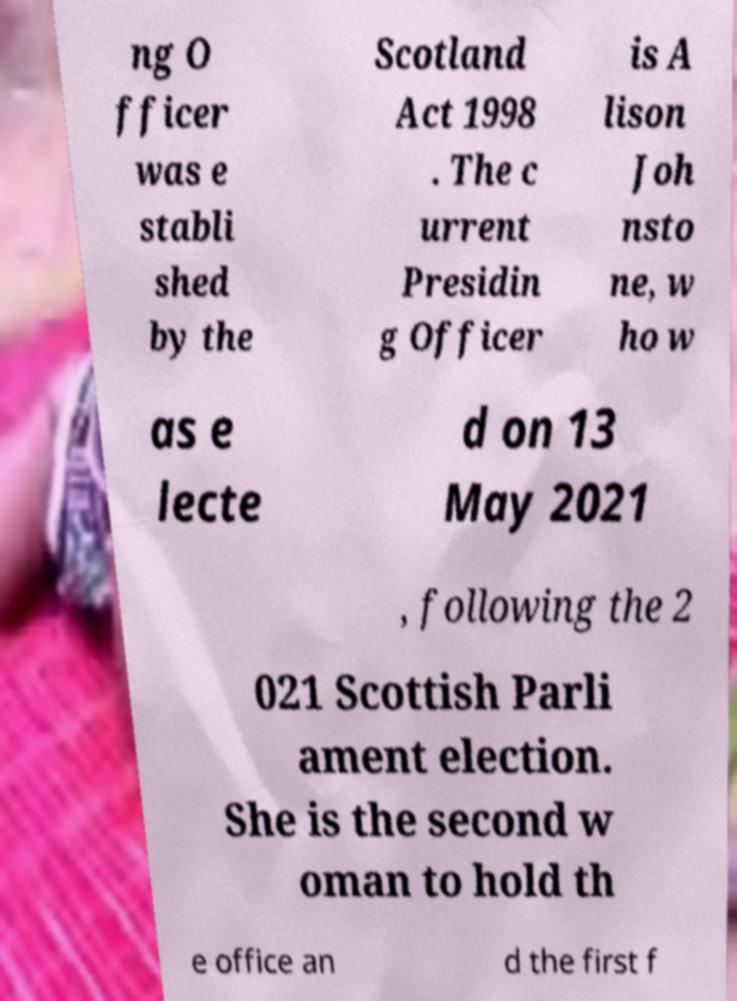Please identify and transcribe the text found in this image. ng O fficer was e stabli shed by the Scotland Act 1998 . The c urrent Presidin g Officer is A lison Joh nsto ne, w ho w as e lecte d on 13 May 2021 , following the 2 021 Scottish Parli ament election. She is the second w oman to hold th e office an d the first f 